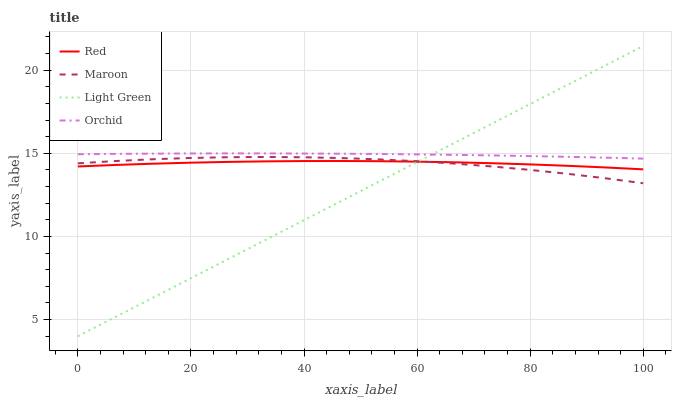Does Light Green have the minimum area under the curve?
Answer yes or no. Yes. Does Orchid have the maximum area under the curve?
Answer yes or no. Yes. Does Maroon have the minimum area under the curve?
Answer yes or no. No. Does Maroon have the maximum area under the curve?
Answer yes or no. No. Is Light Green the smoothest?
Answer yes or no. Yes. Is Maroon the roughest?
Answer yes or no. Yes. Is Red the smoothest?
Answer yes or no. No. Is Red the roughest?
Answer yes or no. No. Does Light Green have the lowest value?
Answer yes or no. Yes. Does Maroon have the lowest value?
Answer yes or no. No. Does Light Green have the highest value?
Answer yes or no. Yes. Does Maroon have the highest value?
Answer yes or no. No. Is Red less than Orchid?
Answer yes or no. Yes. Is Orchid greater than Red?
Answer yes or no. Yes. Does Light Green intersect Orchid?
Answer yes or no. Yes. Is Light Green less than Orchid?
Answer yes or no. No. Is Light Green greater than Orchid?
Answer yes or no. No. Does Red intersect Orchid?
Answer yes or no. No. 